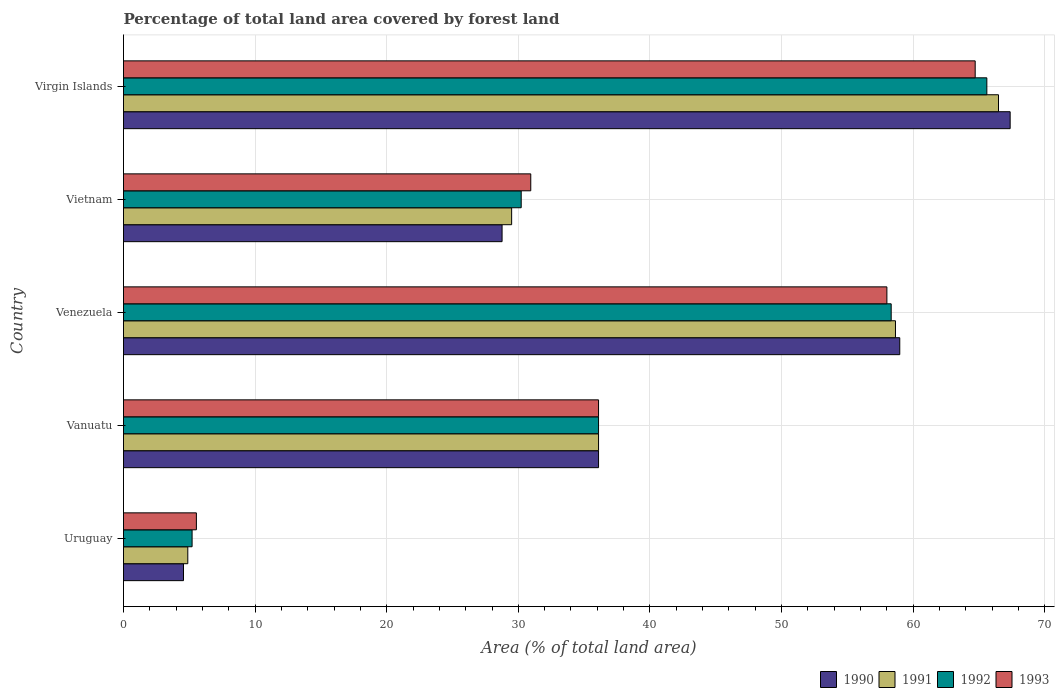How many groups of bars are there?
Offer a terse response. 5. Are the number of bars per tick equal to the number of legend labels?
Your answer should be compact. Yes. Are the number of bars on each tick of the Y-axis equal?
Keep it short and to the point. Yes. How many bars are there on the 5th tick from the top?
Keep it short and to the point. 4. What is the label of the 1st group of bars from the top?
Offer a very short reply. Virgin Islands. In how many cases, is the number of bars for a given country not equal to the number of legend labels?
Offer a terse response. 0. What is the percentage of forest land in 1992 in Vietnam?
Offer a very short reply. 30.22. Across all countries, what is the maximum percentage of forest land in 1993?
Your answer should be very brief. 64.71. Across all countries, what is the minimum percentage of forest land in 1992?
Make the answer very short. 5.21. In which country was the percentage of forest land in 1990 maximum?
Provide a short and direct response. Virgin Islands. In which country was the percentage of forest land in 1993 minimum?
Keep it short and to the point. Uruguay. What is the total percentage of forest land in 1992 in the graph?
Keep it short and to the point. 195.46. What is the difference between the percentage of forest land in 1990 in Venezuela and that in Virgin Islands?
Keep it short and to the point. -8.39. What is the difference between the percentage of forest land in 1990 in Vanuatu and the percentage of forest land in 1992 in Uruguay?
Ensure brevity in your answer.  30.88. What is the average percentage of forest land in 1992 per country?
Give a very brief answer. 39.09. What is the difference between the percentage of forest land in 1992 and percentage of forest land in 1993 in Vietnam?
Provide a short and direct response. -0.73. What is the ratio of the percentage of forest land in 1991 in Uruguay to that in Virgin Islands?
Make the answer very short. 0.07. Is the percentage of forest land in 1993 in Vanuatu less than that in Virgin Islands?
Your answer should be very brief. Yes. Is the difference between the percentage of forest land in 1992 in Vanuatu and Venezuela greater than the difference between the percentage of forest land in 1993 in Vanuatu and Venezuela?
Keep it short and to the point. No. What is the difference between the highest and the second highest percentage of forest land in 1992?
Provide a succinct answer. 7.27. What is the difference between the highest and the lowest percentage of forest land in 1990?
Keep it short and to the point. 62.81. Is the sum of the percentage of forest land in 1992 in Uruguay and Vietnam greater than the maximum percentage of forest land in 1993 across all countries?
Keep it short and to the point. No. What does the 4th bar from the bottom in Virgin Islands represents?
Offer a very short reply. 1993. How many bars are there?
Provide a short and direct response. 20. Does the graph contain grids?
Your response must be concise. Yes. Where does the legend appear in the graph?
Your answer should be compact. Bottom right. How many legend labels are there?
Provide a succinct answer. 4. What is the title of the graph?
Your response must be concise. Percentage of total land area covered by forest land. What is the label or title of the X-axis?
Your answer should be compact. Area (% of total land area). What is the label or title of the Y-axis?
Keep it short and to the point. Country. What is the Area (% of total land area) of 1990 in Uruguay?
Your answer should be compact. 4.56. What is the Area (% of total land area) of 1991 in Uruguay?
Give a very brief answer. 4.89. What is the Area (% of total land area) of 1992 in Uruguay?
Ensure brevity in your answer.  5.21. What is the Area (% of total land area) in 1993 in Uruguay?
Ensure brevity in your answer.  5.54. What is the Area (% of total land area) in 1990 in Vanuatu?
Provide a short and direct response. 36.1. What is the Area (% of total land area) of 1991 in Vanuatu?
Offer a terse response. 36.1. What is the Area (% of total land area) in 1992 in Vanuatu?
Your answer should be very brief. 36.1. What is the Area (% of total land area) of 1993 in Vanuatu?
Offer a terse response. 36.1. What is the Area (% of total land area) in 1990 in Venezuela?
Make the answer very short. 58.98. What is the Area (% of total land area) in 1991 in Venezuela?
Your answer should be very brief. 58.66. What is the Area (% of total land area) in 1992 in Venezuela?
Provide a succinct answer. 58.33. What is the Area (% of total land area) of 1993 in Venezuela?
Give a very brief answer. 58.01. What is the Area (% of total land area) in 1990 in Vietnam?
Your response must be concise. 28.77. What is the Area (% of total land area) in 1991 in Vietnam?
Keep it short and to the point. 29.49. What is the Area (% of total land area) of 1992 in Vietnam?
Keep it short and to the point. 30.22. What is the Area (% of total land area) in 1993 in Vietnam?
Your answer should be very brief. 30.94. What is the Area (% of total land area) of 1990 in Virgin Islands?
Provide a succinct answer. 67.37. What is the Area (% of total land area) in 1991 in Virgin Islands?
Ensure brevity in your answer.  66.49. What is the Area (% of total land area) in 1992 in Virgin Islands?
Provide a short and direct response. 65.6. What is the Area (% of total land area) of 1993 in Virgin Islands?
Give a very brief answer. 64.71. Across all countries, what is the maximum Area (% of total land area) of 1990?
Give a very brief answer. 67.37. Across all countries, what is the maximum Area (% of total land area) of 1991?
Your answer should be compact. 66.49. Across all countries, what is the maximum Area (% of total land area) in 1992?
Your response must be concise. 65.6. Across all countries, what is the maximum Area (% of total land area) in 1993?
Your response must be concise. 64.71. Across all countries, what is the minimum Area (% of total land area) of 1990?
Provide a succinct answer. 4.56. Across all countries, what is the minimum Area (% of total land area) of 1991?
Your answer should be compact. 4.89. Across all countries, what is the minimum Area (% of total land area) in 1992?
Your answer should be compact. 5.21. Across all countries, what is the minimum Area (% of total land area) of 1993?
Offer a terse response. 5.54. What is the total Area (% of total land area) in 1990 in the graph?
Offer a very short reply. 195.77. What is the total Area (% of total land area) of 1991 in the graph?
Give a very brief answer. 195.62. What is the total Area (% of total land area) of 1992 in the graph?
Ensure brevity in your answer.  195.46. What is the total Area (% of total land area) of 1993 in the graph?
Provide a succinct answer. 195.3. What is the difference between the Area (% of total land area) in 1990 in Uruguay and that in Vanuatu?
Provide a short and direct response. -31.54. What is the difference between the Area (% of total land area) of 1991 in Uruguay and that in Vanuatu?
Offer a very short reply. -31.21. What is the difference between the Area (% of total land area) in 1992 in Uruguay and that in Vanuatu?
Offer a terse response. -30.88. What is the difference between the Area (% of total land area) in 1993 in Uruguay and that in Vanuatu?
Offer a very short reply. -30.56. What is the difference between the Area (% of total land area) in 1990 in Uruguay and that in Venezuela?
Keep it short and to the point. -54.42. What is the difference between the Area (% of total land area) of 1991 in Uruguay and that in Venezuela?
Your answer should be very brief. -53.77. What is the difference between the Area (% of total land area) of 1992 in Uruguay and that in Venezuela?
Your response must be concise. -53.12. What is the difference between the Area (% of total land area) in 1993 in Uruguay and that in Venezuela?
Keep it short and to the point. -52.47. What is the difference between the Area (% of total land area) in 1990 in Uruguay and that in Vietnam?
Give a very brief answer. -24.21. What is the difference between the Area (% of total land area) of 1991 in Uruguay and that in Vietnam?
Offer a very short reply. -24.61. What is the difference between the Area (% of total land area) of 1992 in Uruguay and that in Vietnam?
Ensure brevity in your answer.  -25.01. What is the difference between the Area (% of total land area) of 1993 in Uruguay and that in Vietnam?
Ensure brevity in your answer.  -25.41. What is the difference between the Area (% of total land area) of 1990 in Uruguay and that in Virgin Islands?
Your answer should be very brief. -62.81. What is the difference between the Area (% of total land area) in 1991 in Uruguay and that in Virgin Islands?
Provide a short and direct response. -61.6. What is the difference between the Area (% of total land area) in 1992 in Uruguay and that in Virgin Islands?
Give a very brief answer. -60.39. What is the difference between the Area (% of total land area) of 1993 in Uruguay and that in Virgin Islands?
Your response must be concise. -59.18. What is the difference between the Area (% of total land area) of 1990 in Vanuatu and that in Venezuela?
Keep it short and to the point. -22.89. What is the difference between the Area (% of total land area) of 1991 in Vanuatu and that in Venezuela?
Provide a succinct answer. -22.56. What is the difference between the Area (% of total land area) of 1992 in Vanuatu and that in Venezuela?
Ensure brevity in your answer.  -22.24. What is the difference between the Area (% of total land area) in 1993 in Vanuatu and that in Venezuela?
Your answer should be compact. -21.91. What is the difference between the Area (% of total land area) in 1990 in Vanuatu and that in Vietnam?
Your answer should be very brief. 7.33. What is the difference between the Area (% of total land area) in 1991 in Vanuatu and that in Vietnam?
Make the answer very short. 6.6. What is the difference between the Area (% of total land area) of 1992 in Vanuatu and that in Vietnam?
Offer a very short reply. 5.88. What is the difference between the Area (% of total land area) of 1993 in Vanuatu and that in Vietnam?
Ensure brevity in your answer.  5.15. What is the difference between the Area (% of total land area) in 1990 in Vanuatu and that in Virgin Islands?
Your response must be concise. -31.28. What is the difference between the Area (% of total land area) of 1991 in Vanuatu and that in Virgin Islands?
Offer a very short reply. -30.39. What is the difference between the Area (% of total land area) in 1992 in Vanuatu and that in Virgin Islands?
Provide a short and direct response. -29.5. What is the difference between the Area (% of total land area) of 1993 in Vanuatu and that in Virgin Islands?
Give a very brief answer. -28.62. What is the difference between the Area (% of total land area) of 1990 in Venezuela and that in Vietnam?
Your answer should be compact. 30.22. What is the difference between the Area (% of total land area) of 1991 in Venezuela and that in Vietnam?
Give a very brief answer. 29.16. What is the difference between the Area (% of total land area) of 1992 in Venezuela and that in Vietnam?
Keep it short and to the point. 28.11. What is the difference between the Area (% of total land area) of 1993 in Venezuela and that in Vietnam?
Keep it short and to the point. 27.06. What is the difference between the Area (% of total land area) in 1990 in Venezuela and that in Virgin Islands?
Your response must be concise. -8.39. What is the difference between the Area (% of total land area) in 1991 in Venezuela and that in Virgin Islands?
Ensure brevity in your answer.  -7.83. What is the difference between the Area (% of total land area) in 1992 in Venezuela and that in Virgin Islands?
Provide a short and direct response. -7.27. What is the difference between the Area (% of total land area) of 1993 in Venezuela and that in Virgin Islands?
Offer a terse response. -6.71. What is the difference between the Area (% of total land area) in 1990 in Vietnam and that in Virgin Islands?
Keep it short and to the point. -38.61. What is the difference between the Area (% of total land area) in 1991 in Vietnam and that in Virgin Islands?
Your response must be concise. -36.99. What is the difference between the Area (% of total land area) of 1992 in Vietnam and that in Virgin Islands?
Your answer should be very brief. -35.38. What is the difference between the Area (% of total land area) of 1993 in Vietnam and that in Virgin Islands?
Offer a terse response. -33.77. What is the difference between the Area (% of total land area) of 1990 in Uruguay and the Area (% of total land area) of 1991 in Vanuatu?
Offer a very short reply. -31.54. What is the difference between the Area (% of total land area) of 1990 in Uruguay and the Area (% of total land area) of 1992 in Vanuatu?
Offer a very short reply. -31.54. What is the difference between the Area (% of total land area) in 1990 in Uruguay and the Area (% of total land area) in 1993 in Vanuatu?
Make the answer very short. -31.54. What is the difference between the Area (% of total land area) of 1991 in Uruguay and the Area (% of total land area) of 1992 in Vanuatu?
Ensure brevity in your answer.  -31.21. What is the difference between the Area (% of total land area) of 1991 in Uruguay and the Area (% of total land area) of 1993 in Vanuatu?
Keep it short and to the point. -31.21. What is the difference between the Area (% of total land area) in 1992 in Uruguay and the Area (% of total land area) in 1993 in Vanuatu?
Offer a very short reply. -30.88. What is the difference between the Area (% of total land area) of 1990 in Uruguay and the Area (% of total land area) of 1991 in Venezuela?
Your answer should be compact. -54.1. What is the difference between the Area (% of total land area) in 1990 in Uruguay and the Area (% of total land area) in 1992 in Venezuela?
Provide a short and direct response. -53.77. What is the difference between the Area (% of total land area) in 1990 in Uruguay and the Area (% of total land area) in 1993 in Venezuela?
Your answer should be compact. -53.45. What is the difference between the Area (% of total land area) in 1991 in Uruguay and the Area (% of total land area) in 1992 in Venezuela?
Your answer should be compact. -53.45. What is the difference between the Area (% of total land area) of 1991 in Uruguay and the Area (% of total land area) of 1993 in Venezuela?
Offer a terse response. -53.12. What is the difference between the Area (% of total land area) of 1992 in Uruguay and the Area (% of total land area) of 1993 in Venezuela?
Offer a very short reply. -52.79. What is the difference between the Area (% of total land area) of 1990 in Uruguay and the Area (% of total land area) of 1991 in Vietnam?
Make the answer very short. -24.93. What is the difference between the Area (% of total land area) of 1990 in Uruguay and the Area (% of total land area) of 1992 in Vietnam?
Provide a succinct answer. -25.66. What is the difference between the Area (% of total land area) of 1990 in Uruguay and the Area (% of total land area) of 1993 in Vietnam?
Your answer should be compact. -26.39. What is the difference between the Area (% of total land area) of 1991 in Uruguay and the Area (% of total land area) of 1992 in Vietnam?
Provide a short and direct response. -25.33. What is the difference between the Area (% of total land area) of 1991 in Uruguay and the Area (% of total land area) of 1993 in Vietnam?
Your response must be concise. -26.06. What is the difference between the Area (% of total land area) of 1992 in Uruguay and the Area (% of total land area) of 1993 in Vietnam?
Provide a succinct answer. -25.73. What is the difference between the Area (% of total land area) in 1990 in Uruguay and the Area (% of total land area) in 1991 in Virgin Islands?
Make the answer very short. -61.93. What is the difference between the Area (% of total land area) in 1990 in Uruguay and the Area (% of total land area) in 1992 in Virgin Islands?
Keep it short and to the point. -61.04. What is the difference between the Area (% of total land area) in 1990 in Uruguay and the Area (% of total land area) in 1993 in Virgin Islands?
Make the answer very short. -60.16. What is the difference between the Area (% of total land area) in 1991 in Uruguay and the Area (% of total land area) in 1992 in Virgin Islands?
Ensure brevity in your answer.  -60.71. What is the difference between the Area (% of total land area) in 1991 in Uruguay and the Area (% of total land area) in 1993 in Virgin Islands?
Provide a succinct answer. -59.83. What is the difference between the Area (% of total land area) of 1992 in Uruguay and the Area (% of total land area) of 1993 in Virgin Islands?
Provide a succinct answer. -59.5. What is the difference between the Area (% of total land area) in 1990 in Vanuatu and the Area (% of total land area) in 1991 in Venezuela?
Make the answer very short. -22.56. What is the difference between the Area (% of total land area) of 1990 in Vanuatu and the Area (% of total land area) of 1992 in Venezuela?
Provide a short and direct response. -22.24. What is the difference between the Area (% of total land area) of 1990 in Vanuatu and the Area (% of total land area) of 1993 in Venezuela?
Provide a short and direct response. -21.91. What is the difference between the Area (% of total land area) in 1991 in Vanuatu and the Area (% of total land area) in 1992 in Venezuela?
Your response must be concise. -22.24. What is the difference between the Area (% of total land area) in 1991 in Vanuatu and the Area (% of total land area) in 1993 in Venezuela?
Keep it short and to the point. -21.91. What is the difference between the Area (% of total land area) of 1992 in Vanuatu and the Area (% of total land area) of 1993 in Venezuela?
Make the answer very short. -21.91. What is the difference between the Area (% of total land area) of 1990 in Vanuatu and the Area (% of total land area) of 1991 in Vietnam?
Offer a very short reply. 6.6. What is the difference between the Area (% of total land area) in 1990 in Vanuatu and the Area (% of total land area) in 1992 in Vietnam?
Make the answer very short. 5.88. What is the difference between the Area (% of total land area) of 1990 in Vanuatu and the Area (% of total land area) of 1993 in Vietnam?
Your response must be concise. 5.15. What is the difference between the Area (% of total land area) in 1991 in Vanuatu and the Area (% of total land area) in 1992 in Vietnam?
Offer a terse response. 5.88. What is the difference between the Area (% of total land area) in 1991 in Vanuatu and the Area (% of total land area) in 1993 in Vietnam?
Offer a very short reply. 5.15. What is the difference between the Area (% of total land area) of 1992 in Vanuatu and the Area (% of total land area) of 1993 in Vietnam?
Keep it short and to the point. 5.15. What is the difference between the Area (% of total land area) in 1990 in Vanuatu and the Area (% of total land area) in 1991 in Virgin Islands?
Provide a short and direct response. -30.39. What is the difference between the Area (% of total land area) in 1990 in Vanuatu and the Area (% of total land area) in 1992 in Virgin Islands?
Ensure brevity in your answer.  -29.5. What is the difference between the Area (% of total land area) of 1990 in Vanuatu and the Area (% of total land area) of 1993 in Virgin Islands?
Provide a succinct answer. -28.62. What is the difference between the Area (% of total land area) of 1991 in Vanuatu and the Area (% of total land area) of 1992 in Virgin Islands?
Your answer should be very brief. -29.5. What is the difference between the Area (% of total land area) of 1991 in Vanuatu and the Area (% of total land area) of 1993 in Virgin Islands?
Keep it short and to the point. -28.62. What is the difference between the Area (% of total land area) in 1992 in Vanuatu and the Area (% of total land area) in 1993 in Virgin Islands?
Give a very brief answer. -28.62. What is the difference between the Area (% of total land area) in 1990 in Venezuela and the Area (% of total land area) in 1991 in Vietnam?
Your answer should be compact. 29.49. What is the difference between the Area (% of total land area) of 1990 in Venezuela and the Area (% of total land area) of 1992 in Vietnam?
Your response must be concise. 28.76. What is the difference between the Area (% of total land area) in 1990 in Venezuela and the Area (% of total land area) in 1993 in Vietnam?
Make the answer very short. 28.04. What is the difference between the Area (% of total land area) of 1991 in Venezuela and the Area (% of total land area) of 1992 in Vietnam?
Offer a very short reply. 28.44. What is the difference between the Area (% of total land area) in 1991 in Venezuela and the Area (% of total land area) in 1993 in Vietnam?
Your response must be concise. 27.71. What is the difference between the Area (% of total land area) in 1992 in Venezuela and the Area (% of total land area) in 1993 in Vietnam?
Offer a very short reply. 27.39. What is the difference between the Area (% of total land area) in 1990 in Venezuela and the Area (% of total land area) in 1991 in Virgin Islands?
Provide a short and direct response. -7.5. What is the difference between the Area (% of total land area) in 1990 in Venezuela and the Area (% of total land area) in 1992 in Virgin Islands?
Provide a short and direct response. -6.62. What is the difference between the Area (% of total land area) of 1990 in Venezuela and the Area (% of total land area) of 1993 in Virgin Islands?
Provide a short and direct response. -5.73. What is the difference between the Area (% of total land area) in 1991 in Venezuela and the Area (% of total land area) in 1992 in Virgin Islands?
Provide a succinct answer. -6.94. What is the difference between the Area (% of total land area) of 1991 in Venezuela and the Area (% of total land area) of 1993 in Virgin Islands?
Provide a short and direct response. -6.06. What is the difference between the Area (% of total land area) of 1992 in Venezuela and the Area (% of total land area) of 1993 in Virgin Islands?
Offer a very short reply. -6.38. What is the difference between the Area (% of total land area) of 1990 in Vietnam and the Area (% of total land area) of 1991 in Virgin Islands?
Your answer should be very brief. -37.72. What is the difference between the Area (% of total land area) of 1990 in Vietnam and the Area (% of total land area) of 1992 in Virgin Islands?
Make the answer very short. -36.83. What is the difference between the Area (% of total land area) in 1990 in Vietnam and the Area (% of total land area) in 1993 in Virgin Islands?
Keep it short and to the point. -35.95. What is the difference between the Area (% of total land area) in 1991 in Vietnam and the Area (% of total land area) in 1992 in Virgin Islands?
Offer a terse response. -36.11. What is the difference between the Area (% of total land area) of 1991 in Vietnam and the Area (% of total land area) of 1993 in Virgin Islands?
Offer a very short reply. -35.22. What is the difference between the Area (% of total land area) in 1992 in Vietnam and the Area (% of total land area) in 1993 in Virgin Islands?
Offer a very short reply. -34.5. What is the average Area (% of total land area) of 1990 per country?
Your response must be concise. 39.15. What is the average Area (% of total land area) of 1991 per country?
Your answer should be compact. 39.12. What is the average Area (% of total land area) of 1992 per country?
Provide a succinct answer. 39.09. What is the average Area (% of total land area) in 1993 per country?
Your answer should be compact. 39.06. What is the difference between the Area (% of total land area) in 1990 and Area (% of total land area) in 1991 in Uruguay?
Offer a terse response. -0.33. What is the difference between the Area (% of total land area) in 1990 and Area (% of total land area) in 1992 in Uruguay?
Ensure brevity in your answer.  -0.65. What is the difference between the Area (% of total land area) in 1990 and Area (% of total land area) in 1993 in Uruguay?
Your answer should be very brief. -0.98. What is the difference between the Area (% of total land area) of 1991 and Area (% of total land area) of 1992 in Uruguay?
Ensure brevity in your answer.  -0.33. What is the difference between the Area (% of total land area) of 1991 and Area (% of total land area) of 1993 in Uruguay?
Offer a terse response. -0.65. What is the difference between the Area (% of total land area) in 1992 and Area (% of total land area) in 1993 in Uruguay?
Ensure brevity in your answer.  -0.33. What is the difference between the Area (% of total land area) in 1990 and Area (% of total land area) in 1991 in Vanuatu?
Ensure brevity in your answer.  0. What is the difference between the Area (% of total land area) of 1990 and Area (% of total land area) of 1992 in Vanuatu?
Offer a terse response. 0. What is the difference between the Area (% of total land area) in 1990 and Area (% of total land area) in 1993 in Vanuatu?
Offer a terse response. 0. What is the difference between the Area (% of total land area) of 1991 and Area (% of total land area) of 1992 in Vanuatu?
Offer a terse response. 0. What is the difference between the Area (% of total land area) in 1991 and Area (% of total land area) in 1993 in Vanuatu?
Ensure brevity in your answer.  0. What is the difference between the Area (% of total land area) in 1990 and Area (% of total land area) in 1991 in Venezuela?
Give a very brief answer. 0.33. What is the difference between the Area (% of total land area) of 1990 and Area (% of total land area) of 1992 in Venezuela?
Ensure brevity in your answer.  0.65. What is the difference between the Area (% of total land area) in 1990 and Area (% of total land area) in 1993 in Venezuela?
Ensure brevity in your answer.  0.98. What is the difference between the Area (% of total land area) in 1991 and Area (% of total land area) in 1992 in Venezuela?
Ensure brevity in your answer.  0.33. What is the difference between the Area (% of total land area) of 1991 and Area (% of total land area) of 1993 in Venezuela?
Provide a succinct answer. 0.65. What is the difference between the Area (% of total land area) in 1992 and Area (% of total land area) in 1993 in Venezuela?
Keep it short and to the point. 0.33. What is the difference between the Area (% of total land area) of 1990 and Area (% of total land area) of 1991 in Vietnam?
Provide a succinct answer. -0.73. What is the difference between the Area (% of total land area) of 1990 and Area (% of total land area) of 1992 in Vietnam?
Ensure brevity in your answer.  -1.45. What is the difference between the Area (% of total land area) of 1990 and Area (% of total land area) of 1993 in Vietnam?
Your answer should be compact. -2.18. What is the difference between the Area (% of total land area) in 1991 and Area (% of total land area) in 1992 in Vietnam?
Provide a short and direct response. -0.73. What is the difference between the Area (% of total land area) of 1991 and Area (% of total land area) of 1993 in Vietnam?
Keep it short and to the point. -1.45. What is the difference between the Area (% of total land area) of 1992 and Area (% of total land area) of 1993 in Vietnam?
Give a very brief answer. -0.73. What is the difference between the Area (% of total land area) of 1990 and Area (% of total land area) of 1991 in Virgin Islands?
Provide a succinct answer. 0.89. What is the difference between the Area (% of total land area) in 1990 and Area (% of total land area) in 1992 in Virgin Islands?
Your response must be concise. 1.77. What is the difference between the Area (% of total land area) of 1990 and Area (% of total land area) of 1993 in Virgin Islands?
Your response must be concise. 2.66. What is the difference between the Area (% of total land area) of 1991 and Area (% of total land area) of 1992 in Virgin Islands?
Ensure brevity in your answer.  0.89. What is the difference between the Area (% of total land area) in 1991 and Area (% of total land area) in 1993 in Virgin Islands?
Your answer should be compact. 1.77. What is the difference between the Area (% of total land area) in 1992 and Area (% of total land area) in 1993 in Virgin Islands?
Make the answer very short. 0.89. What is the ratio of the Area (% of total land area) of 1990 in Uruguay to that in Vanuatu?
Offer a terse response. 0.13. What is the ratio of the Area (% of total land area) in 1991 in Uruguay to that in Vanuatu?
Make the answer very short. 0.14. What is the ratio of the Area (% of total land area) of 1992 in Uruguay to that in Vanuatu?
Offer a very short reply. 0.14. What is the ratio of the Area (% of total land area) of 1993 in Uruguay to that in Vanuatu?
Your answer should be compact. 0.15. What is the ratio of the Area (% of total land area) of 1990 in Uruguay to that in Venezuela?
Your answer should be very brief. 0.08. What is the ratio of the Area (% of total land area) of 1991 in Uruguay to that in Venezuela?
Ensure brevity in your answer.  0.08. What is the ratio of the Area (% of total land area) in 1992 in Uruguay to that in Venezuela?
Offer a terse response. 0.09. What is the ratio of the Area (% of total land area) in 1993 in Uruguay to that in Venezuela?
Your answer should be compact. 0.1. What is the ratio of the Area (% of total land area) of 1990 in Uruguay to that in Vietnam?
Give a very brief answer. 0.16. What is the ratio of the Area (% of total land area) of 1991 in Uruguay to that in Vietnam?
Offer a very short reply. 0.17. What is the ratio of the Area (% of total land area) of 1992 in Uruguay to that in Vietnam?
Keep it short and to the point. 0.17. What is the ratio of the Area (% of total land area) in 1993 in Uruguay to that in Vietnam?
Keep it short and to the point. 0.18. What is the ratio of the Area (% of total land area) in 1990 in Uruguay to that in Virgin Islands?
Your answer should be very brief. 0.07. What is the ratio of the Area (% of total land area) of 1991 in Uruguay to that in Virgin Islands?
Your answer should be very brief. 0.07. What is the ratio of the Area (% of total land area) in 1992 in Uruguay to that in Virgin Islands?
Offer a very short reply. 0.08. What is the ratio of the Area (% of total land area) of 1993 in Uruguay to that in Virgin Islands?
Make the answer very short. 0.09. What is the ratio of the Area (% of total land area) of 1990 in Vanuatu to that in Venezuela?
Ensure brevity in your answer.  0.61. What is the ratio of the Area (% of total land area) in 1991 in Vanuatu to that in Venezuela?
Give a very brief answer. 0.62. What is the ratio of the Area (% of total land area) in 1992 in Vanuatu to that in Venezuela?
Ensure brevity in your answer.  0.62. What is the ratio of the Area (% of total land area) of 1993 in Vanuatu to that in Venezuela?
Your answer should be very brief. 0.62. What is the ratio of the Area (% of total land area) in 1990 in Vanuatu to that in Vietnam?
Offer a terse response. 1.25. What is the ratio of the Area (% of total land area) in 1991 in Vanuatu to that in Vietnam?
Your answer should be very brief. 1.22. What is the ratio of the Area (% of total land area) in 1992 in Vanuatu to that in Vietnam?
Give a very brief answer. 1.19. What is the ratio of the Area (% of total land area) of 1993 in Vanuatu to that in Vietnam?
Keep it short and to the point. 1.17. What is the ratio of the Area (% of total land area) in 1990 in Vanuatu to that in Virgin Islands?
Ensure brevity in your answer.  0.54. What is the ratio of the Area (% of total land area) in 1991 in Vanuatu to that in Virgin Islands?
Make the answer very short. 0.54. What is the ratio of the Area (% of total land area) of 1992 in Vanuatu to that in Virgin Islands?
Your answer should be compact. 0.55. What is the ratio of the Area (% of total land area) in 1993 in Vanuatu to that in Virgin Islands?
Make the answer very short. 0.56. What is the ratio of the Area (% of total land area) of 1990 in Venezuela to that in Vietnam?
Make the answer very short. 2.05. What is the ratio of the Area (% of total land area) in 1991 in Venezuela to that in Vietnam?
Keep it short and to the point. 1.99. What is the ratio of the Area (% of total land area) in 1992 in Venezuela to that in Vietnam?
Your answer should be compact. 1.93. What is the ratio of the Area (% of total land area) of 1993 in Venezuela to that in Vietnam?
Provide a succinct answer. 1.87. What is the ratio of the Area (% of total land area) of 1990 in Venezuela to that in Virgin Islands?
Your response must be concise. 0.88. What is the ratio of the Area (% of total land area) in 1991 in Venezuela to that in Virgin Islands?
Keep it short and to the point. 0.88. What is the ratio of the Area (% of total land area) in 1992 in Venezuela to that in Virgin Islands?
Your answer should be very brief. 0.89. What is the ratio of the Area (% of total land area) of 1993 in Venezuela to that in Virgin Islands?
Your answer should be very brief. 0.9. What is the ratio of the Area (% of total land area) in 1990 in Vietnam to that in Virgin Islands?
Provide a short and direct response. 0.43. What is the ratio of the Area (% of total land area) of 1991 in Vietnam to that in Virgin Islands?
Give a very brief answer. 0.44. What is the ratio of the Area (% of total land area) of 1992 in Vietnam to that in Virgin Islands?
Make the answer very short. 0.46. What is the ratio of the Area (% of total land area) in 1993 in Vietnam to that in Virgin Islands?
Make the answer very short. 0.48. What is the difference between the highest and the second highest Area (% of total land area) of 1990?
Give a very brief answer. 8.39. What is the difference between the highest and the second highest Area (% of total land area) in 1991?
Your answer should be very brief. 7.83. What is the difference between the highest and the second highest Area (% of total land area) of 1992?
Provide a succinct answer. 7.27. What is the difference between the highest and the second highest Area (% of total land area) of 1993?
Ensure brevity in your answer.  6.71. What is the difference between the highest and the lowest Area (% of total land area) of 1990?
Give a very brief answer. 62.81. What is the difference between the highest and the lowest Area (% of total land area) of 1991?
Your response must be concise. 61.6. What is the difference between the highest and the lowest Area (% of total land area) of 1992?
Offer a very short reply. 60.39. What is the difference between the highest and the lowest Area (% of total land area) of 1993?
Your answer should be very brief. 59.18. 